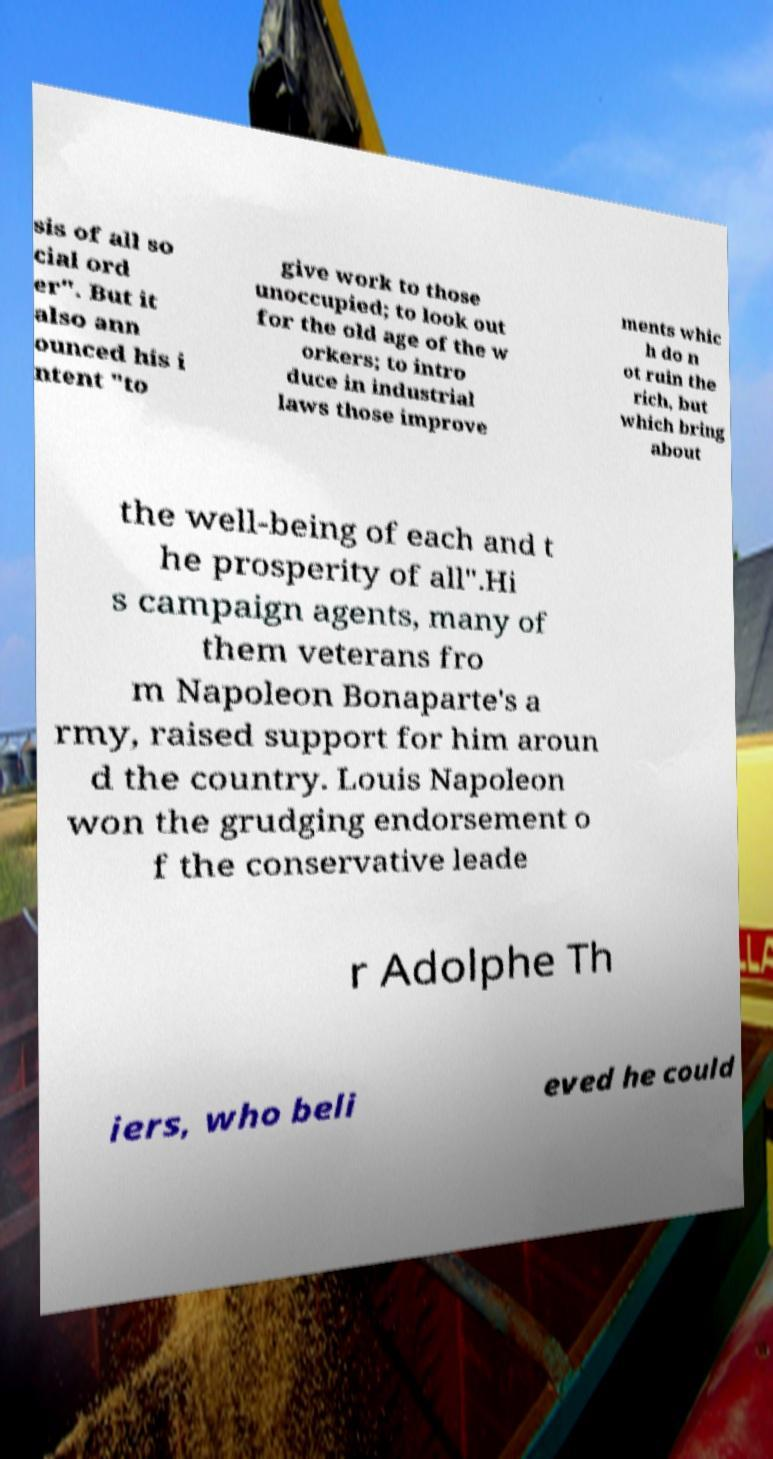Can you read and provide the text displayed in the image?This photo seems to have some interesting text. Can you extract and type it out for me? sis of all so cial ord er". But it also ann ounced his i ntent "to give work to those unoccupied; to look out for the old age of the w orkers; to intro duce in industrial laws those improve ments whic h do n ot ruin the rich, but which bring about the well-being of each and t he prosperity of all".Hi s campaign agents, many of them veterans fro m Napoleon Bonaparte's a rmy, raised support for him aroun d the country. Louis Napoleon won the grudging endorsement o f the conservative leade r Adolphe Th iers, who beli eved he could 